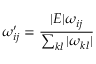Convert formula to latex. <formula><loc_0><loc_0><loc_500><loc_500>\omega _ { i j } ^ { \prime } = \frac { | E | \omega _ { i j } } { \sum _ { k l } | \omega _ { k l } | }</formula> 